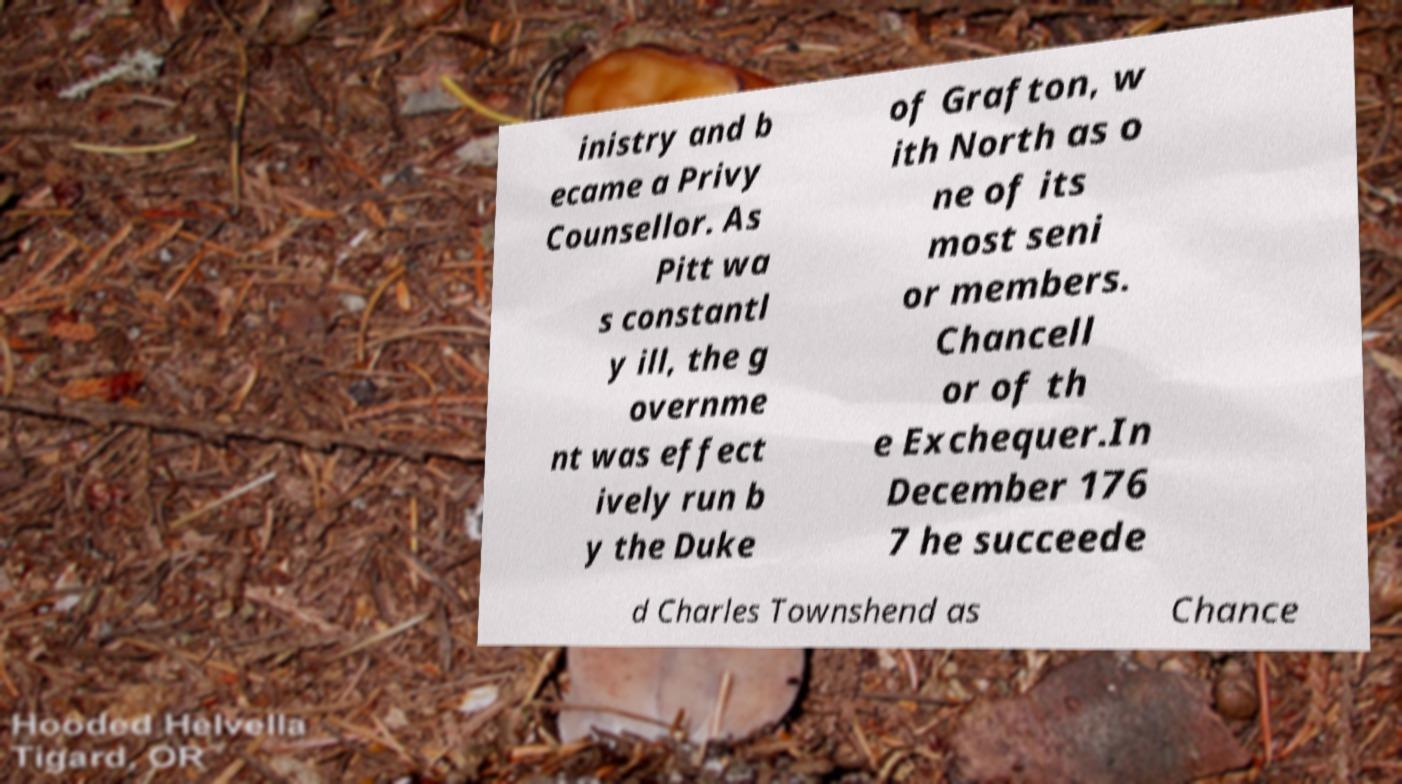There's text embedded in this image that I need extracted. Can you transcribe it verbatim? inistry and b ecame a Privy Counsellor. As Pitt wa s constantl y ill, the g overnme nt was effect ively run b y the Duke of Grafton, w ith North as o ne of its most seni or members. Chancell or of th e Exchequer.In December 176 7 he succeede d Charles Townshend as Chance 